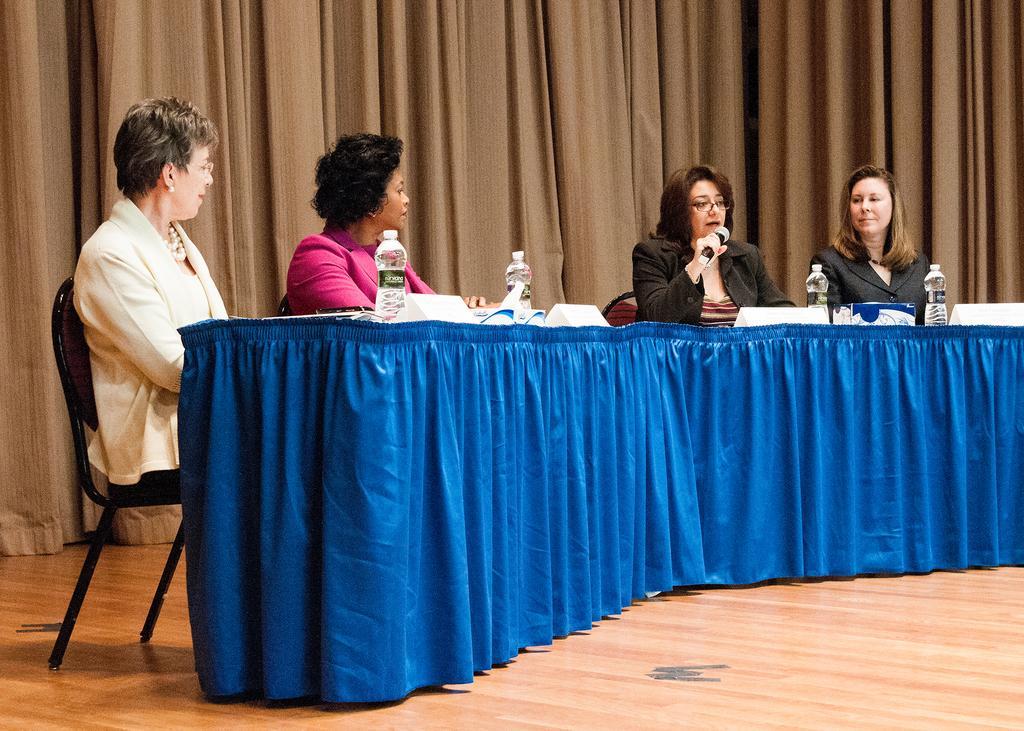In one or two sentences, can you explain what this image depicts? This picture shows five woman Seated on Dais in front there is a table On the table, you can see the water bottles. the third woman speaks with the help of a microphone 